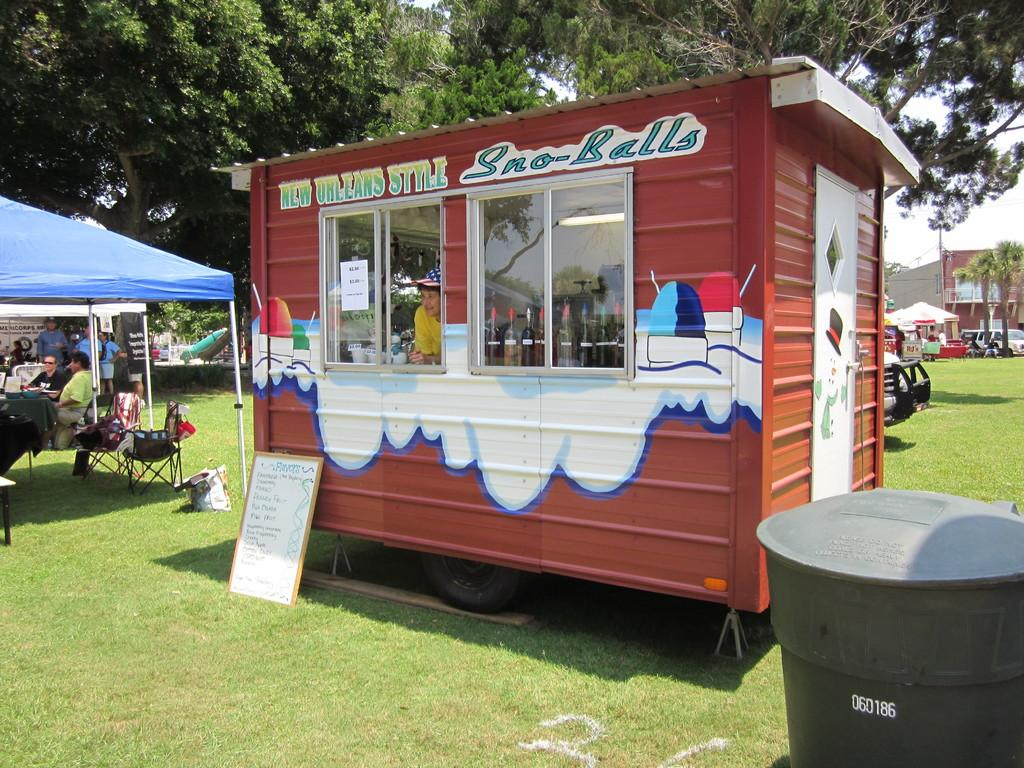Provide a one-sentence caption for the provided image. The sno balls at the stand are New Orleans style. 